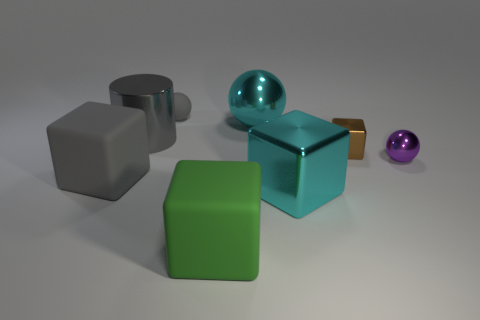Add 1 cubes. How many objects exist? 9 Subtract all cylinders. How many objects are left? 7 Subtract all brown metal blocks. Subtract all big cyan metal things. How many objects are left? 5 Add 7 brown cubes. How many brown cubes are left? 8 Add 3 large balls. How many large balls exist? 4 Subtract 1 cyan spheres. How many objects are left? 7 